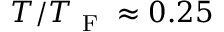<formula> <loc_0><loc_0><loc_500><loc_500>T / T _ { F } \approx 0 . 2 5</formula> 